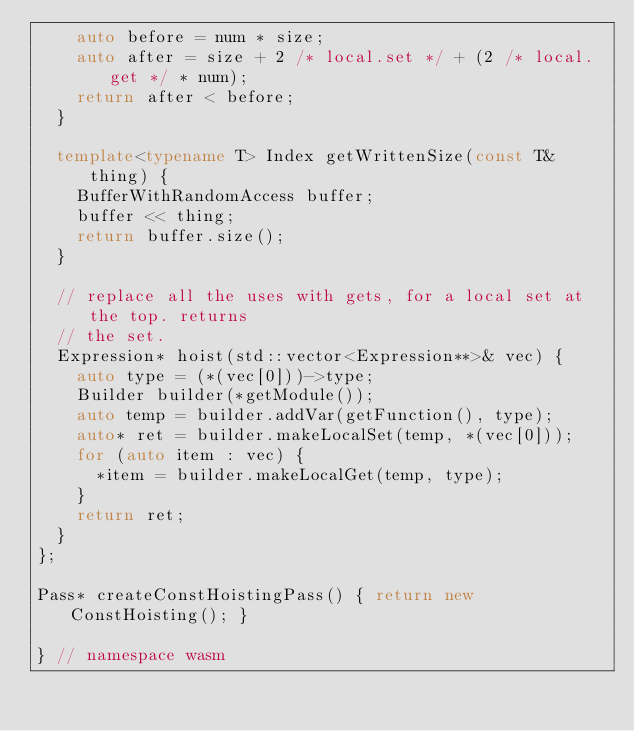Convert code to text. <code><loc_0><loc_0><loc_500><loc_500><_C++_>    auto before = num * size;
    auto after = size + 2 /* local.set */ + (2 /* local.get */ * num);
    return after < before;
  }

  template<typename T> Index getWrittenSize(const T& thing) {
    BufferWithRandomAccess buffer;
    buffer << thing;
    return buffer.size();
  }

  // replace all the uses with gets, for a local set at the top. returns
  // the set.
  Expression* hoist(std::vector<Expression**>& vec) {
    auto type = (*(vec[0]))->type;
    Builder builder(*getModule());
    auto temp = builder.addVar(getFunction(), type);
    auto* ret = builder.makeLocalSet(temp, *(vec[0]));
    for (auto item : vec) {
      *item = builder.makeLocalGet(temp, type);
    }
    return ret;
  }
};

Pass* createConstHoistingPass() { return new ConstHoisting(); }

} // namespace wasm
</code> 